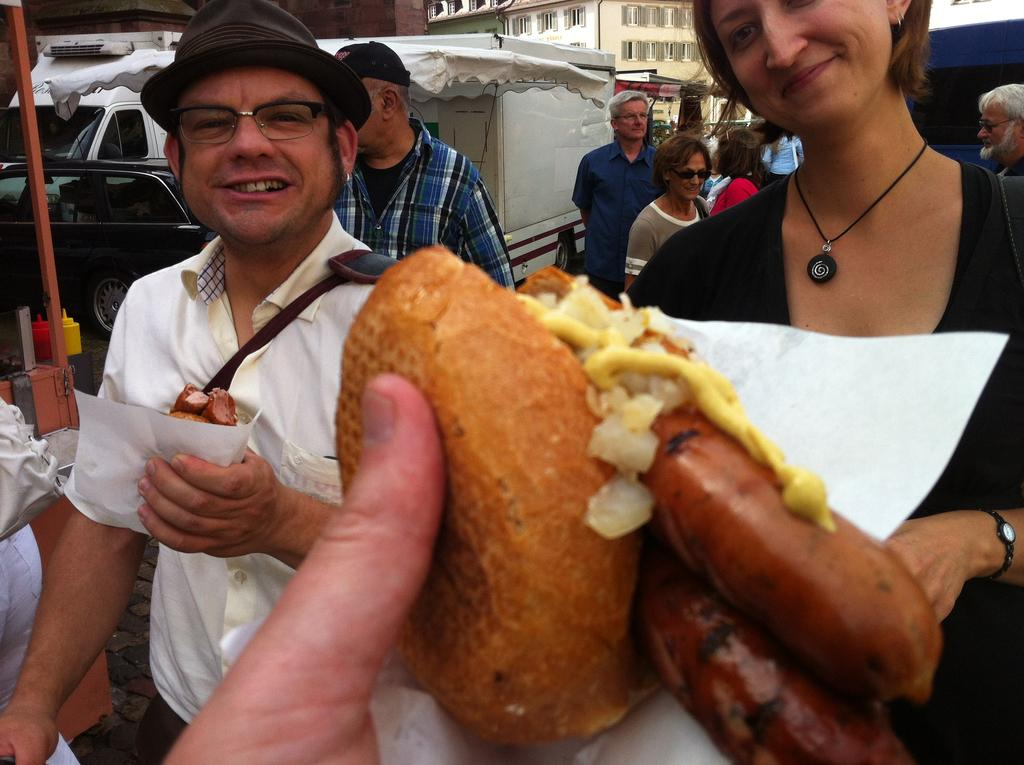What is the hand in the image holding? The hand in the image is holding a food item. What can be seen in the background of the image? There are people, stalls, buildings, and cars in the background of the image. Can you describe the setting of the image? The image appears to be set in an outdoor market or food stall area. How many sheep can be seen grazing in the image? There are no sheep present in the image. What type of dinner is being served at the food stall in the image? The image does not specify the type of food being served, only that a hand is holding a food item. 